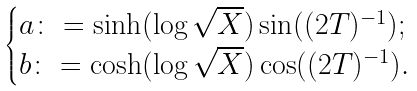Convert formula to latex. <formula><loc_0><loc_0><loc_500><loc_500>\begin{cases} a \colon = \sinh ( \log \sqrt { X } ) \sin ( ( 2 T ) ^ { - 1 } ) ; \\ b \colon = \cosh ( \log \sqrt { X } ) \cos ( ( 2 T ) ^ { - 1 } ) . \end{cases}</formula> 